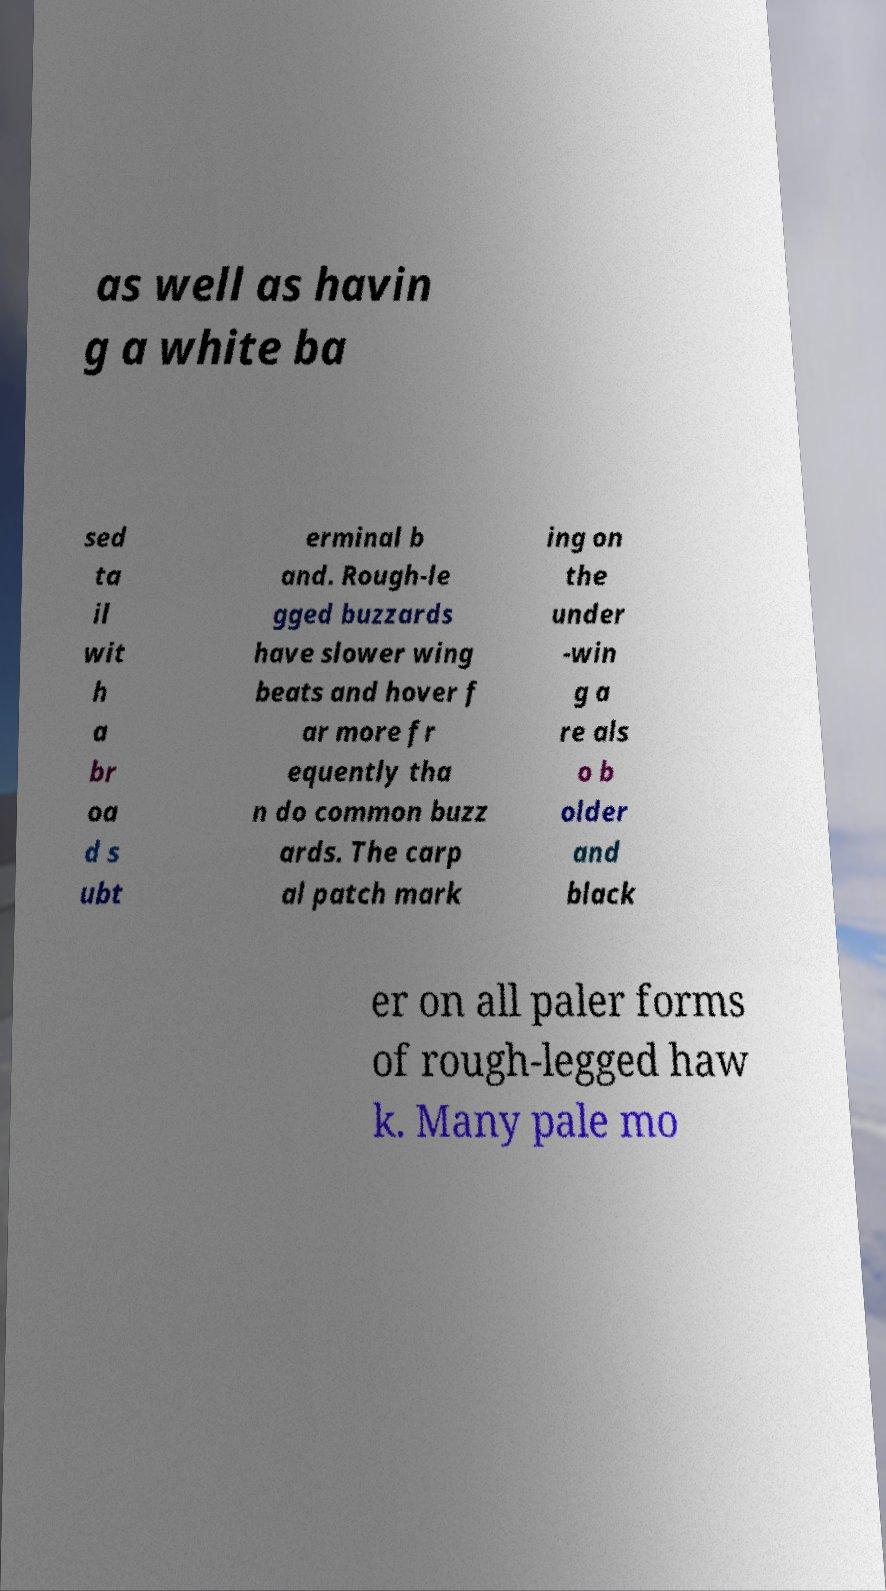I need the written content from this picture converted into text. Can you do that? as well as havin g a white ba sed ta il wit h a br oa d s ubt erminal b and. Rough-le gged buzzards have slower wing beats and hover f ar more fr equently tha n do common buzz ards. The carp al patch mark ing on the under -win g a re als o b older and black er on all paler forms of rough-legged haw k. Many pale mo 